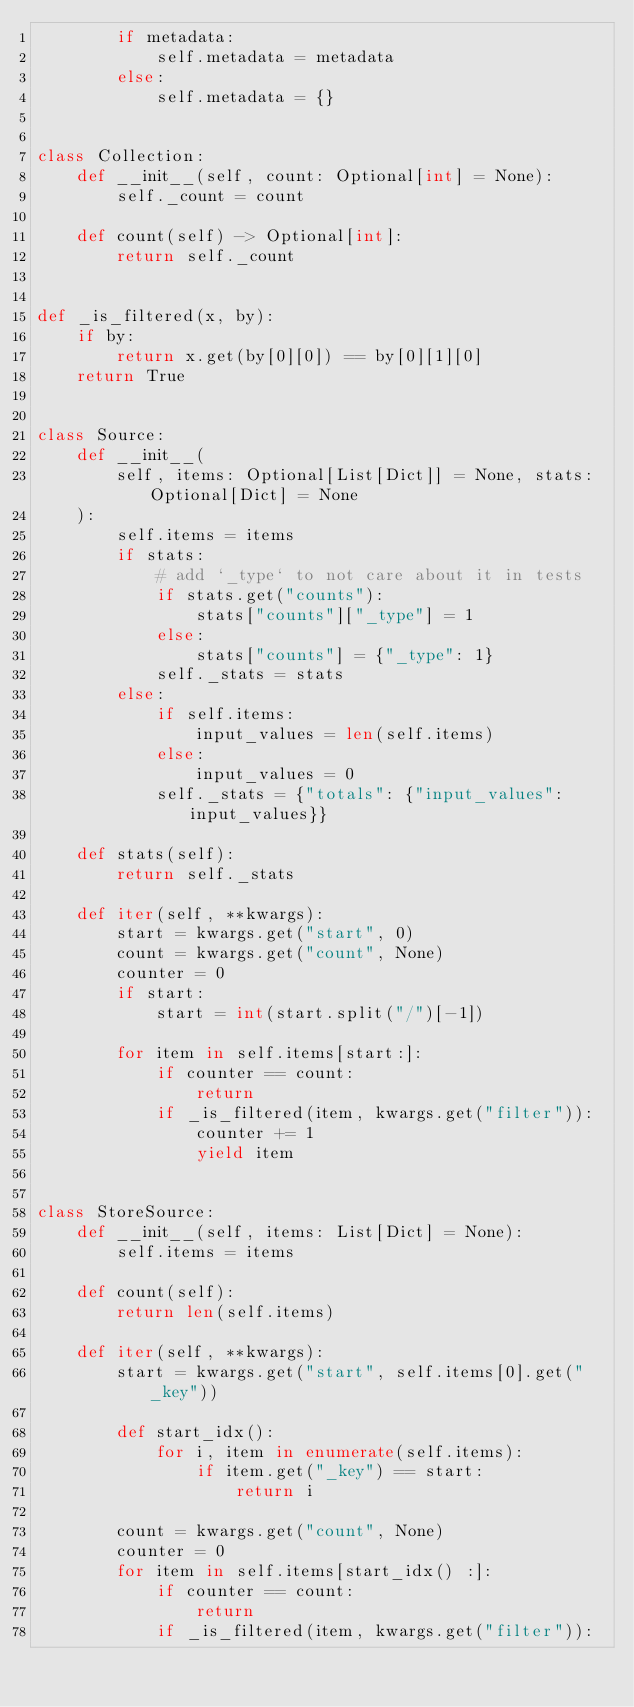<code> <loc_0><loc_0><loc_500><loc_500><_Python_>        if metadata:
            self.metadata = metadata
        else:
            self.metadata = {}


class Collection:
    def __init__(self, count: Optional[int] = None):
        self._count = count

    def count(self) -> Optional[int]:
        return self._count


def _is_filtered(x, by):
    if by:
        return x.get(by[0][0]) == by[0][1][0]
    return True


class Source:
    def __init__(
        self, items: Optional[List[Dict]] = None, stats: Optional[Dict] = None
    ):
        self.items = items
        if stats:
            # add `_type` to not care about it in tests
            if stats.get("counts"):
                stats["counts"]["_type"] = 1
            else:
                stats["counts"] = {"_type": 1}
            self._stats = stats
        else:
            if self.items:
                input_values = len(self.items)
            else:
                input_values = 0
            self._stats = {"totals": {"input_values": input_values}}

    def stats(self):
        return self._stats

    def iter(self, **kwargs):
        start = kwargs.get("start", 0)
        count = kwargs.get("count", None)
        counter = 0
        if start:
            start = int(start.split("/")[-1])

        for item in self.items[start:]:
            if counter == count:
                return
            if _is_filtered(item, kwargs.get("filter")):
                counter += 1
                yield item


class StoreSource:
    def __init__(self, items: List[Dict] = None):
        self.items = items

    def count(self):
        return len(self.items)

    def iter(self, **kwargs):
        start = kwargs.get("start", self.items[0].get("_key"))

        def start_idx():
            for i, item in enumerate(self.items):
                if item.get("_key") == start:
                    return i

        count = kwargs.get("count", None)
        counter = 0
        for item in self.items[start_idx() :]:
            if counter == count:
                return
            if _is_filtered(item, kwargs.get("filter")):</code> 